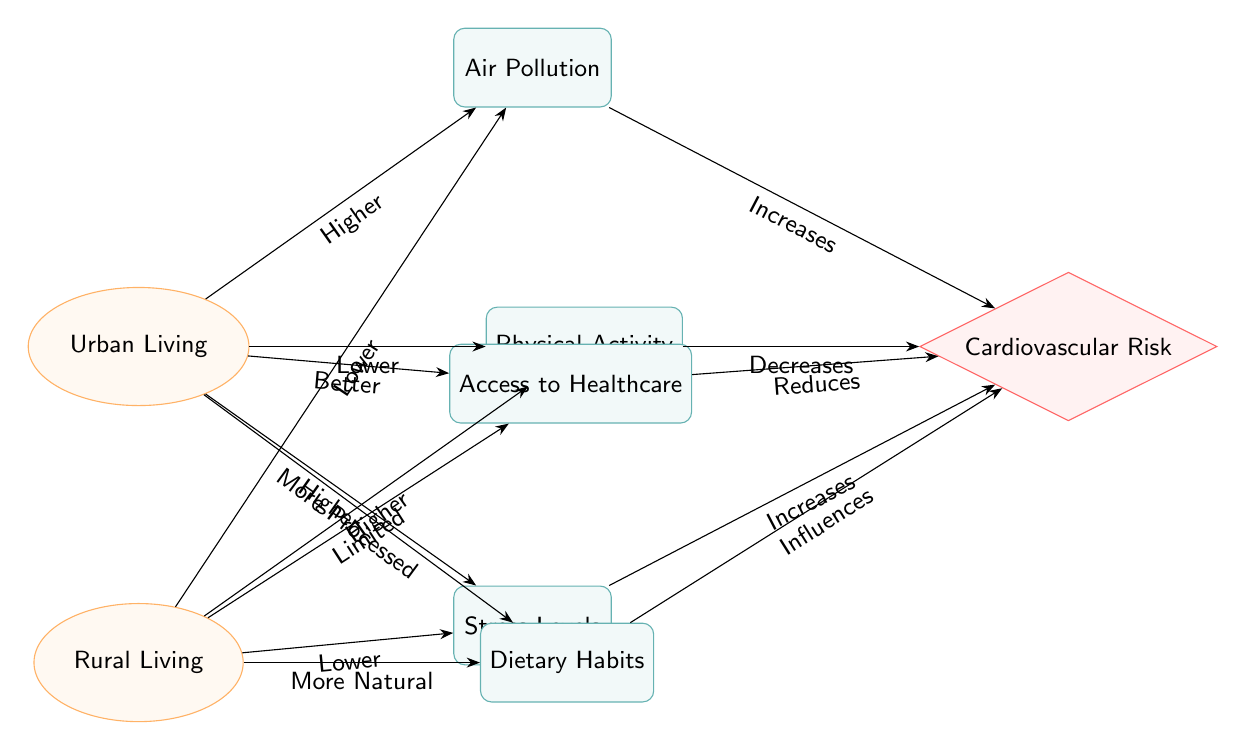What are the living conditions depicted in the diagram? The diagram shows two living conditions: Urban Living and Rural Living. These conditions are represented as nodes in the diagram, specifically categorized under 'living.'
Answer: Urban Living, Rural Living Which factor is associated with higher Cardiovascular Risk in Urban Living? The diagram indicates that Air Pollution increases Cardiovascular Risk when considering Urban Living, making it a significant factor in that condition.
Answer: Air Pollution How do stress levels affect cardiovascular risk in urban areas? In the diagram, it is stated that Higher Stress Levels in Urban Living increases Cardiovascular Risk. Therefore, it directly influences the risk through this relationship.
Answer: Increases What is the impact of dietary habits in Rural Living? The diagram illustrates that dietary habits in Rural Living are categorized as More Natural, which can have a positive influence by reducing Cardiovascular Risk compared to processed diets.
Answer: More Natural How many factors are associated with Urban Living in the diagram? By examining the diagram, there are three factors directly associated with Urban Living: Air Pollution, Physical Activity, and Stress Levels, indicating their direct impact on Cardiovascular Health.
Answer: Three Which node represents the access to healthcare in Rural Living? The factor that represents Access to Healthcare in Rural Living is specifically identified in the diagram and plays a role in influencing cardiovascular health risks in that living condition.
Answer: Access to Healthcare What effect does physical activity have on cardiovascular risk according to the diagram? The diagram indicates that Higher Physical Activity in Rural Living decreases Cardiovascular Risk, thus having a protective effect on cardiovascular health.
Answer: Decreases What is the relationship between air pollution and cardiovascular risk in urban areas? The diagram establishes that Air Pollution is a contributing factor in Urban Living and is labeled as increasing Cardiovascular Risk, showing a direct negative relationship.
Answer: Increases What type of diet is shown to influence cardiovascular risk in urban areas? In the Urban Living section of the diagram, it indicates that dietary habits are categorized as More Processed, which is linked to a higher risk of cardiovascular issues.
Answer: More Processed 